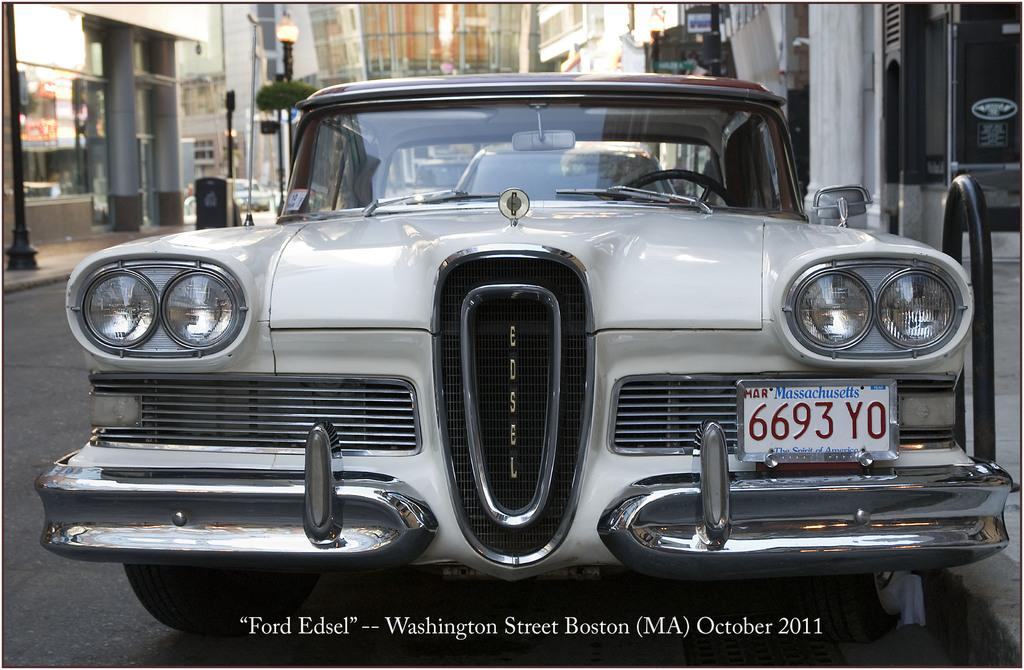<image>
Render a clear and concise summary of the photo. A vintage Edsel car with a Massachussetts tag that reads6693 YO. 